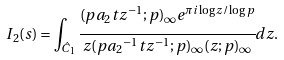Convert formula to latex. <formula><loc_0><loc_0><loc_500><loc_500>I _ { 2 } ( s ) = \int _ { \hat { C } _ { 1 } } \cfrac { ( p a _ { 2 } t z ^ { - 1 } ; p ) _ { \infty } e ^ { \pi i \log z / \log p } } { z ( p { a _ { 2 } } ^ { - 1 } t z ^ { - 1 } ; p ) _ { \infty } ( z ; p ) _ { \infty } } d z .</formula> 